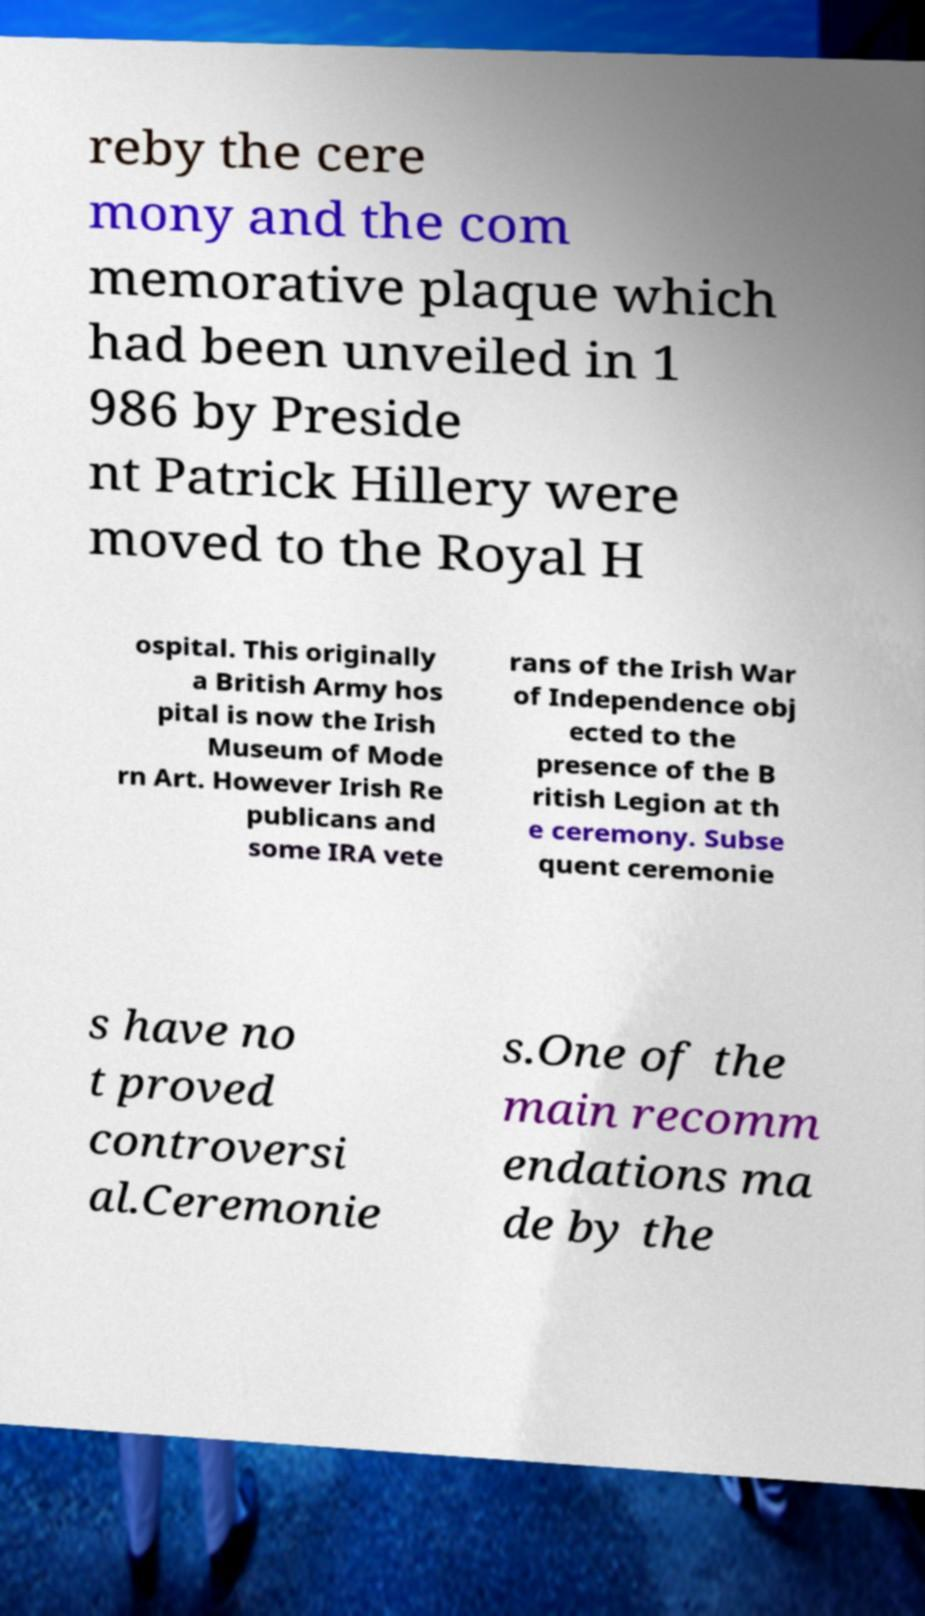Could you extract and type out the text from this image? reby the cere mony and the com memorative plaque which had been unveiled in 1 986 by Preside nt Patrick Hillery were moved to the Royal H ospital. This originally a British Army hos pital is now the Irish Museum of Mode rn Art. However Irish Re publicans and some IRA vete rans of the Irish War of Independence obj ected to the presence of the B ritish Legion at th e ceremony. Subse quent ceremonie s have no t proved controversi al.Ceremonie s.One of the main recomm endations ma de by the 